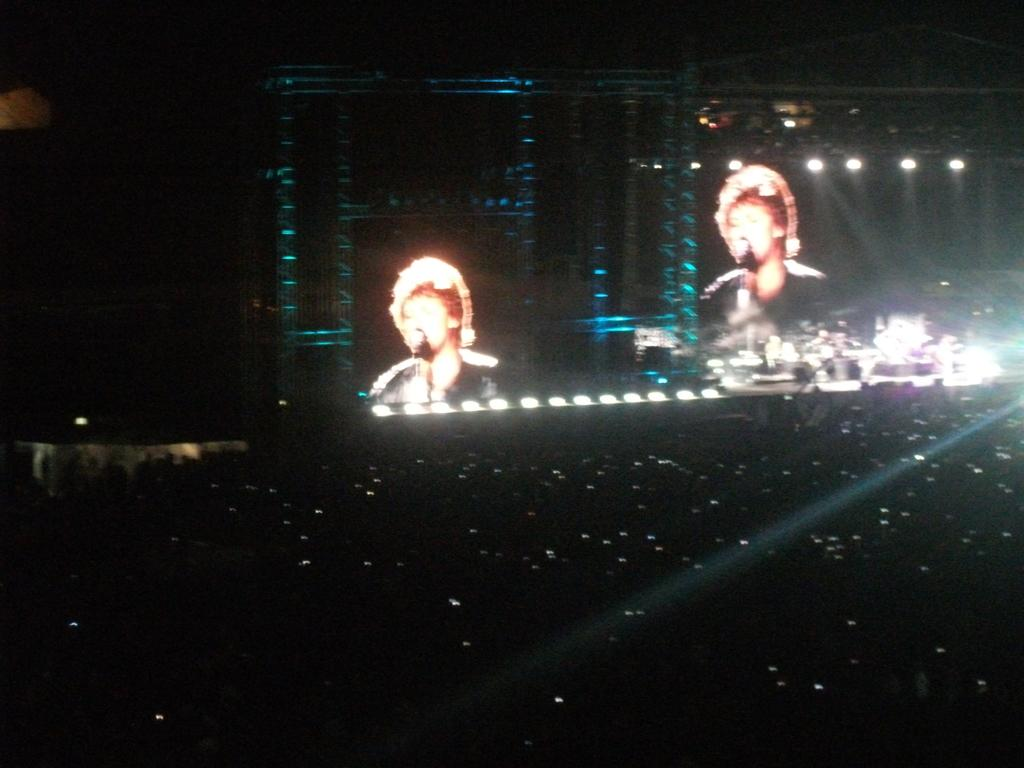What is the main feature of the image? The main feature of the image is the projected screens. What else can be seen in the image besides the screens? There are lights visible in the image. How would you describe the overall setting of the image? The background of the image is dark. How many ants can be seen crawling on the hand in the image? There is no hand or ants present in the image; it only features projected screens and lights. 